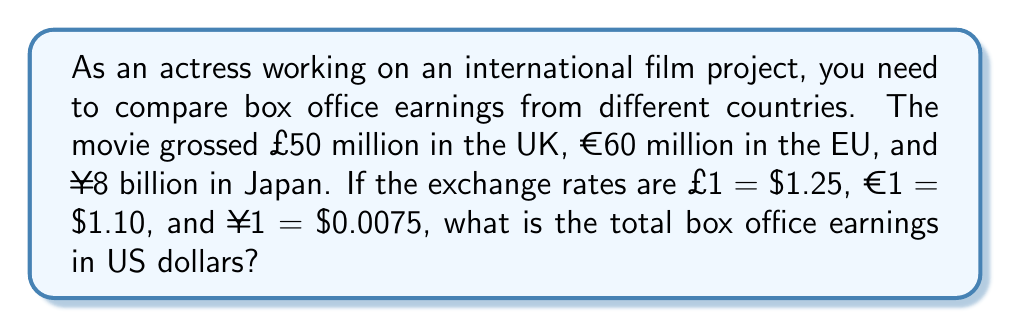Can you answer this question? To solve this problem, we need to convert each currency to US dollars and then sum the results. Let's break it down step by step:

1. Convert UK earnings (£) to USD:
   $$£50 \text{ million} \times \frac{\$1.25}{£1} = \$62.5 \text{ million}$$

2. Convert EU earnings (€) to USD:
   $$€60 \text{ million} \times \frac{\$1.10}{€1} = \$66 \text{ million}$$

3. Convert Japanese earnings (¥) to USD:
   $$¥8 \text{ billion} \times \frac{\$0.0075}{¥1} = \$60 \text{ million}$$

4. Sum up all the converted amounts:
   $$\$62.5 \text{ million} + \$66 \text{ million} + \$60 \text{ million} = \$188.5 \text{ million}$$

Therefore, the total box office earnings in US dollars is $188.5 million.
Answer: $188.5 million 